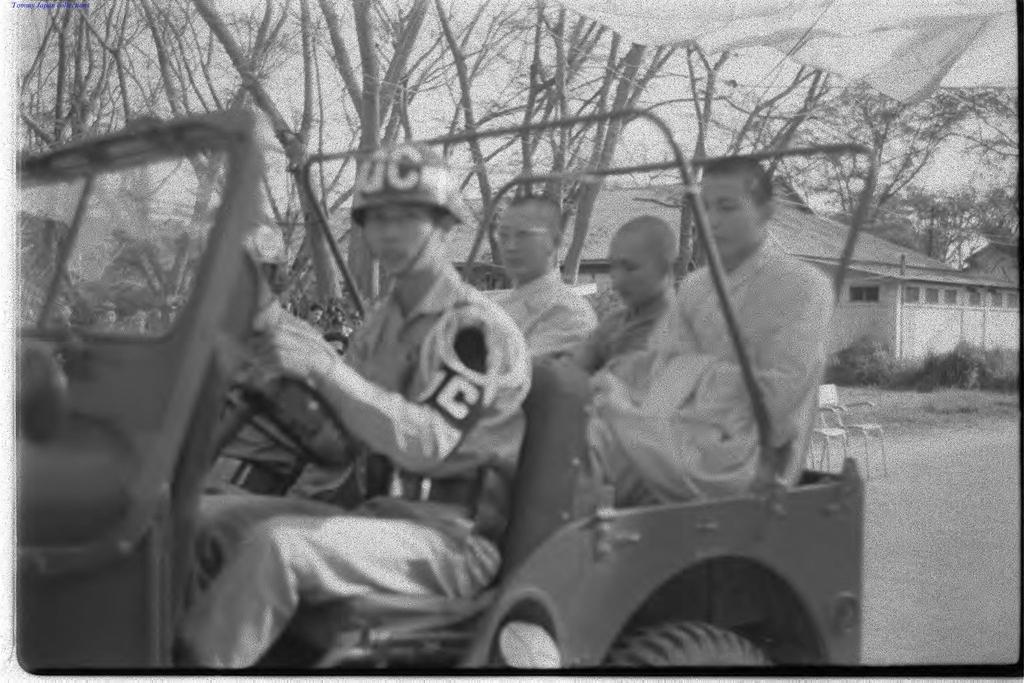In one or two sentences, can you explain what this image depicts? In this picture there are few persons sitting in a vehicle which is on the road and there are trees and a house in the background. 